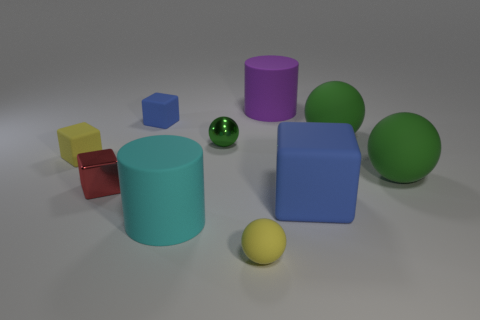Subtract all green blocks. How many green balls are left? 3 Subtract all gray balls. Subtract all yellow cylinders. How many balls are left? 4 Subtract all blocks. How many objects are left? 6 Add 1 red shiny things. How many red shiny things are left? 2 Add 6 big cyan matte cylinders. How many big cyan matte cylinders exist? 7 Subtract 0 cyan balls. How many objects are left? 10 Subtract all purple rubber objects. Subtract all purple objects. How many objects are left? 8 